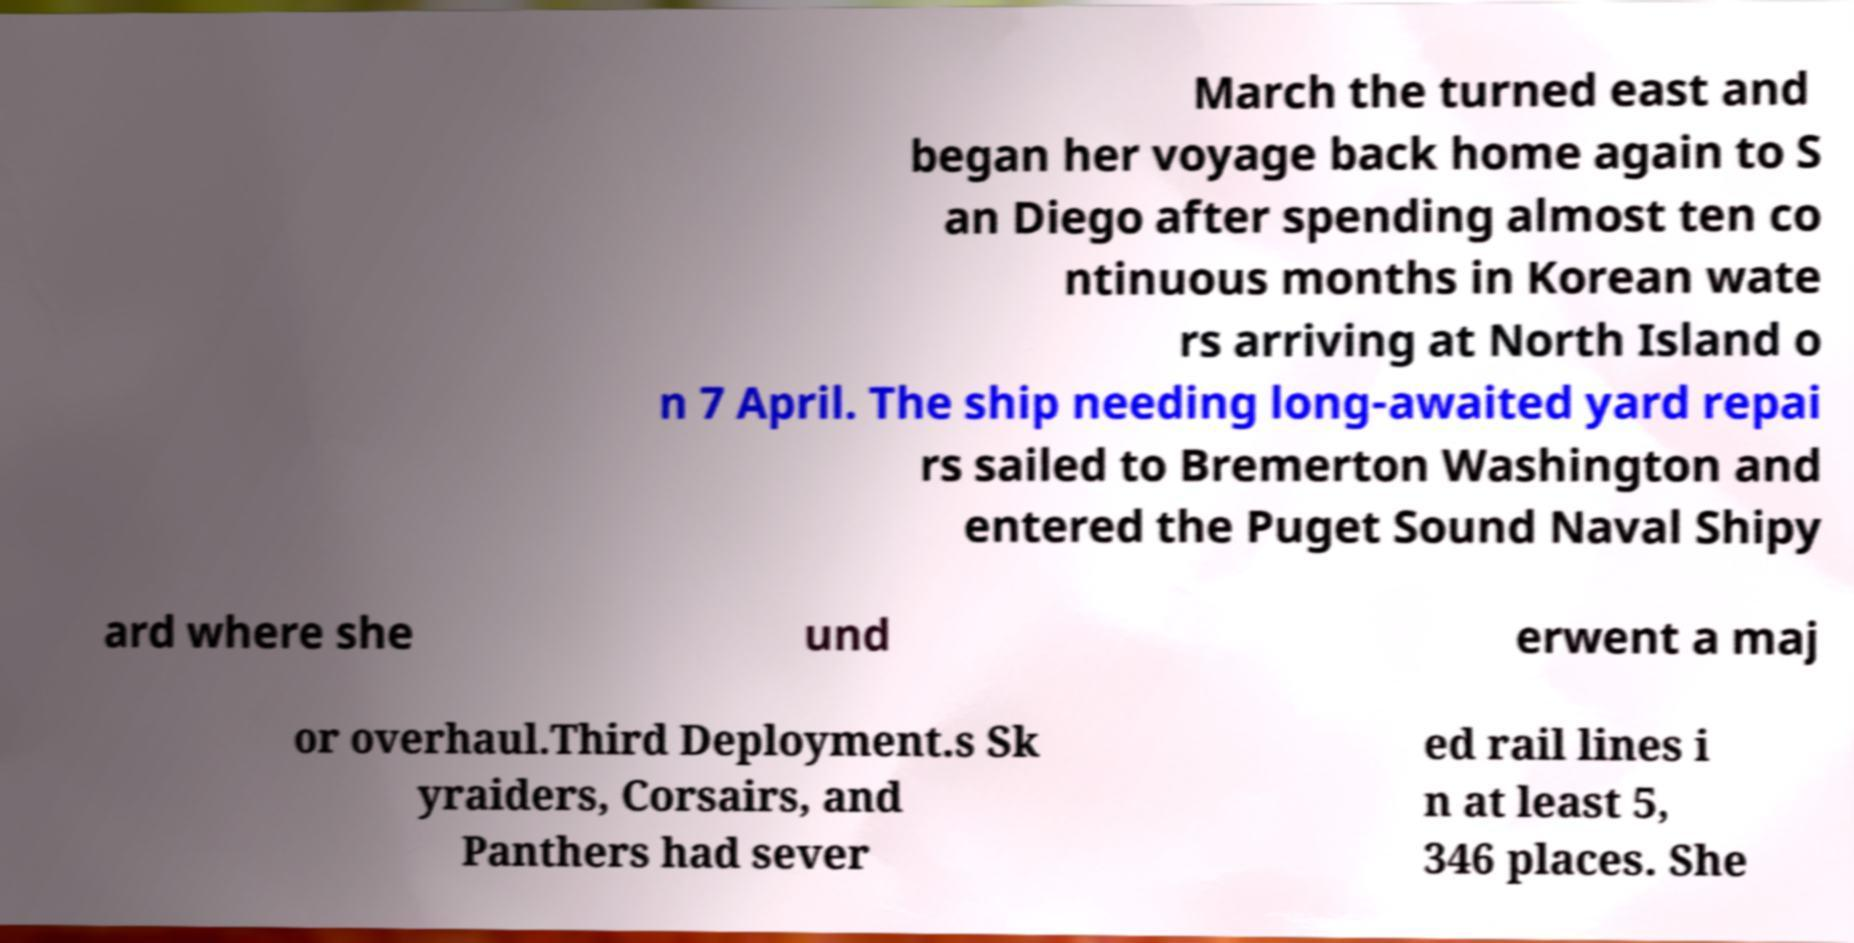Please identify and transcribe the text found in this image. March the turned east and began her voyage back home again to S an Diego after spending almost ten co ntinuous months in Korean wate rs arriving at North Island o n 7 April. The ship needing long-awaited yard repai rs sailed to Bremerton Washington and entered the Puget Sound Naval Shipy ard where she und erwent a maj or overhaul.Third Deployment.s Sk yraiders, Corsairs, and Panthers had sever ed rail lines i n at least 5, 346 places. She 